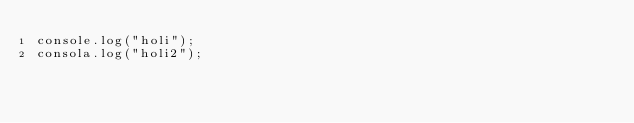Convert code to text. <code><loc_0><loc_0><loc_500><loc_500><_JavaScript_>console.log("holi");
consola.log("holi2");
</code> 